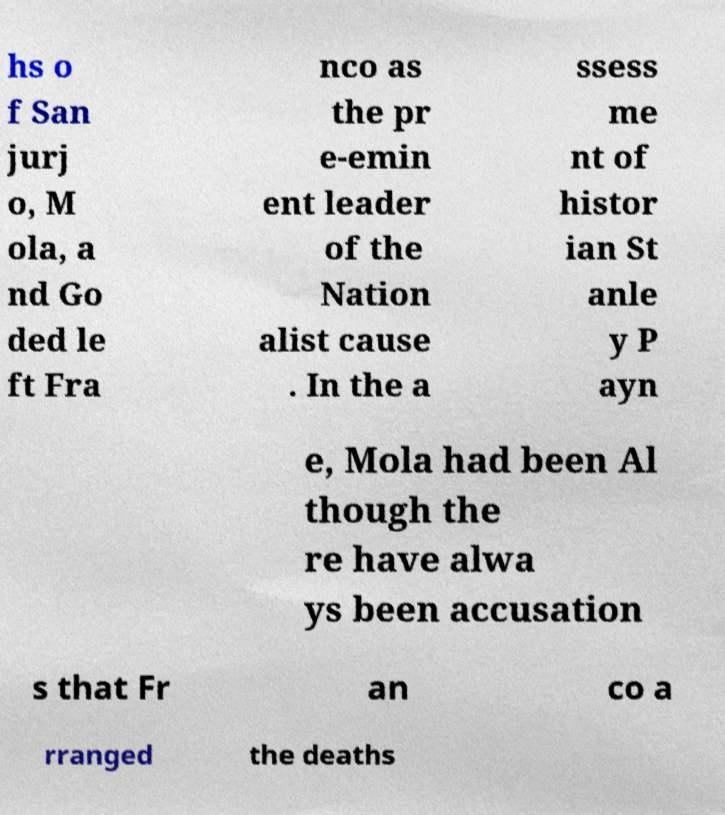Could you extract and type out the text from this image? hs o f San jurj o, M ola, a nd Go ded le ft Fra nco as the pr e-emin ent leader of the Nation alist cause . In the a ssess me nt of histor ian St anle y P ayn e, Mola had been Al though the re have alwa ys been accusation s that Fr an co a rranged the deaths 